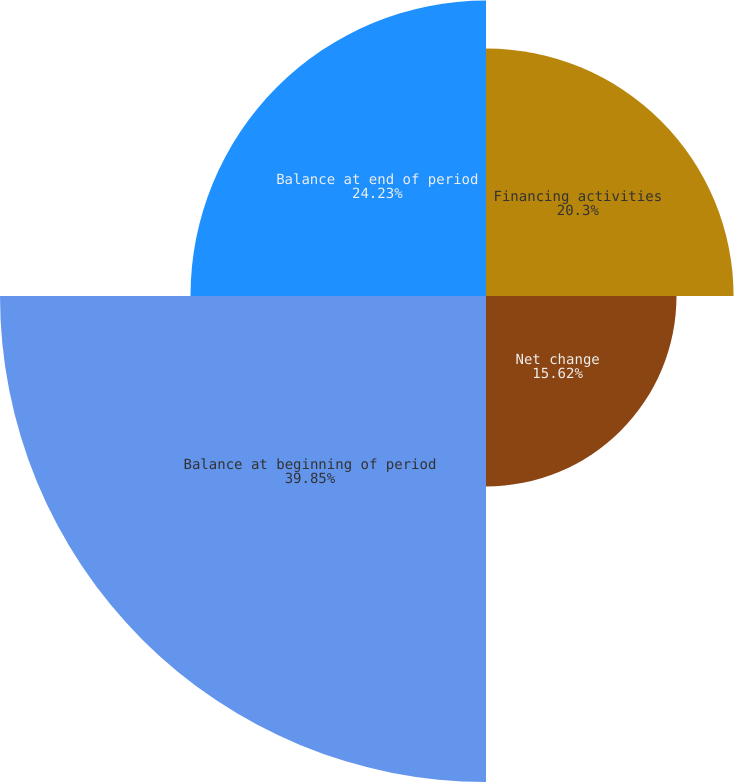<chart> <loc_0><loc_0><loc_500><loc_500><pie_chart><fcel>Financing activities<fcel>Net change<fcel>Balance at beginning of period<fcel>Balance at end of period<nl><fcel>20.3%<fcel>15.62%<fcel>39.85%<fcel>24.23%<nl></chart> 